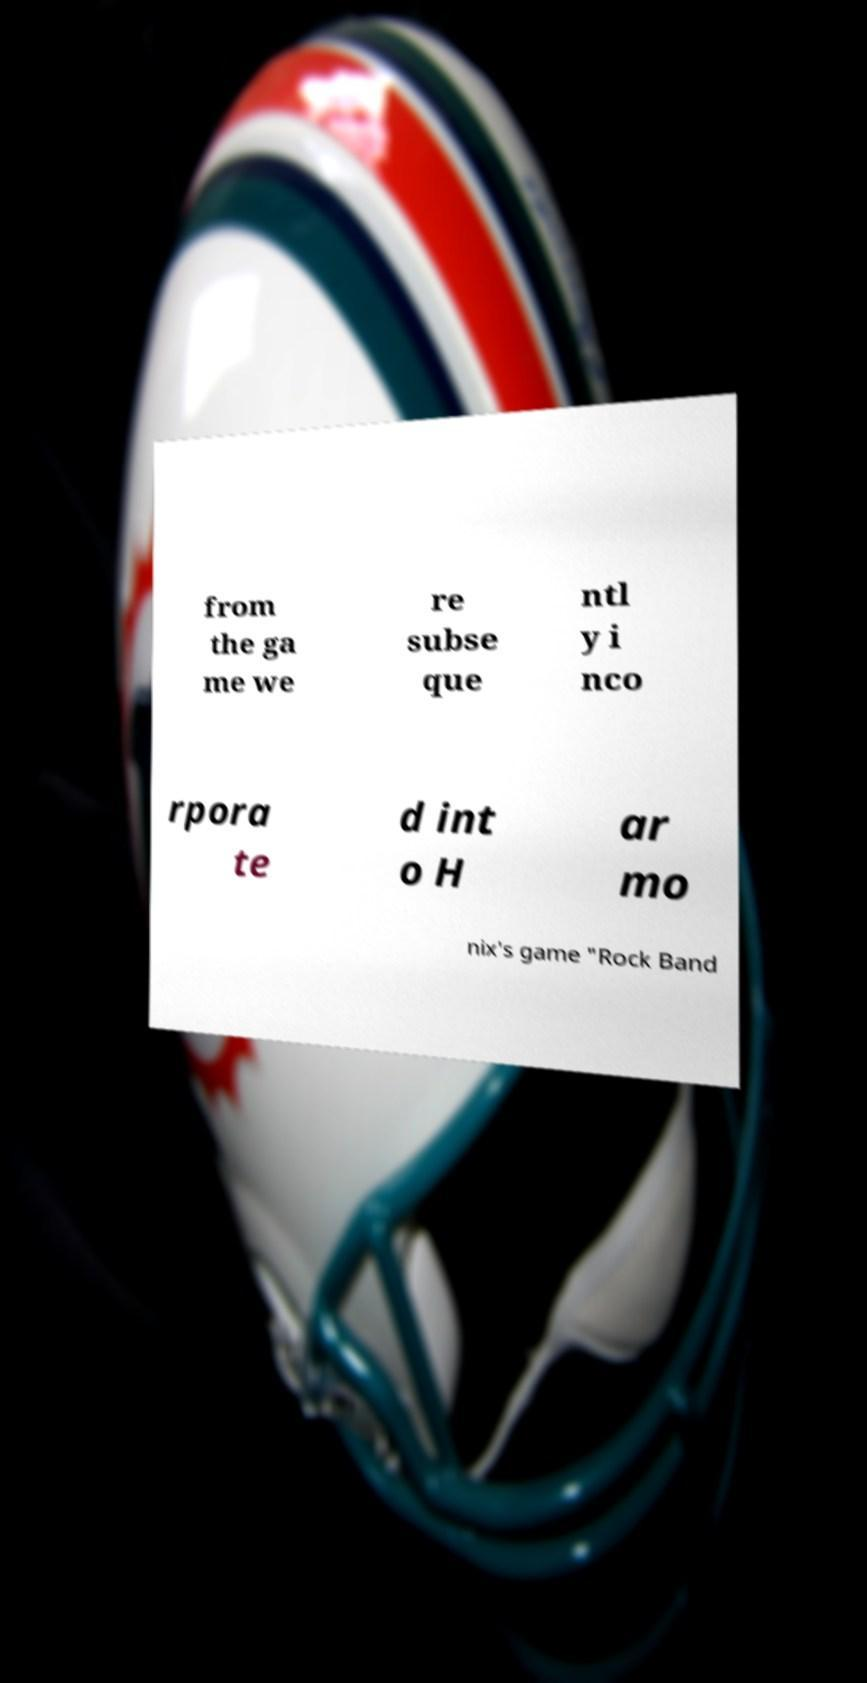I need the written content from this picture converted into text. Can you do that? from the ga me we re subse que ntl y i nco rpora te d int o H ar mo nix's game "Rock Band 